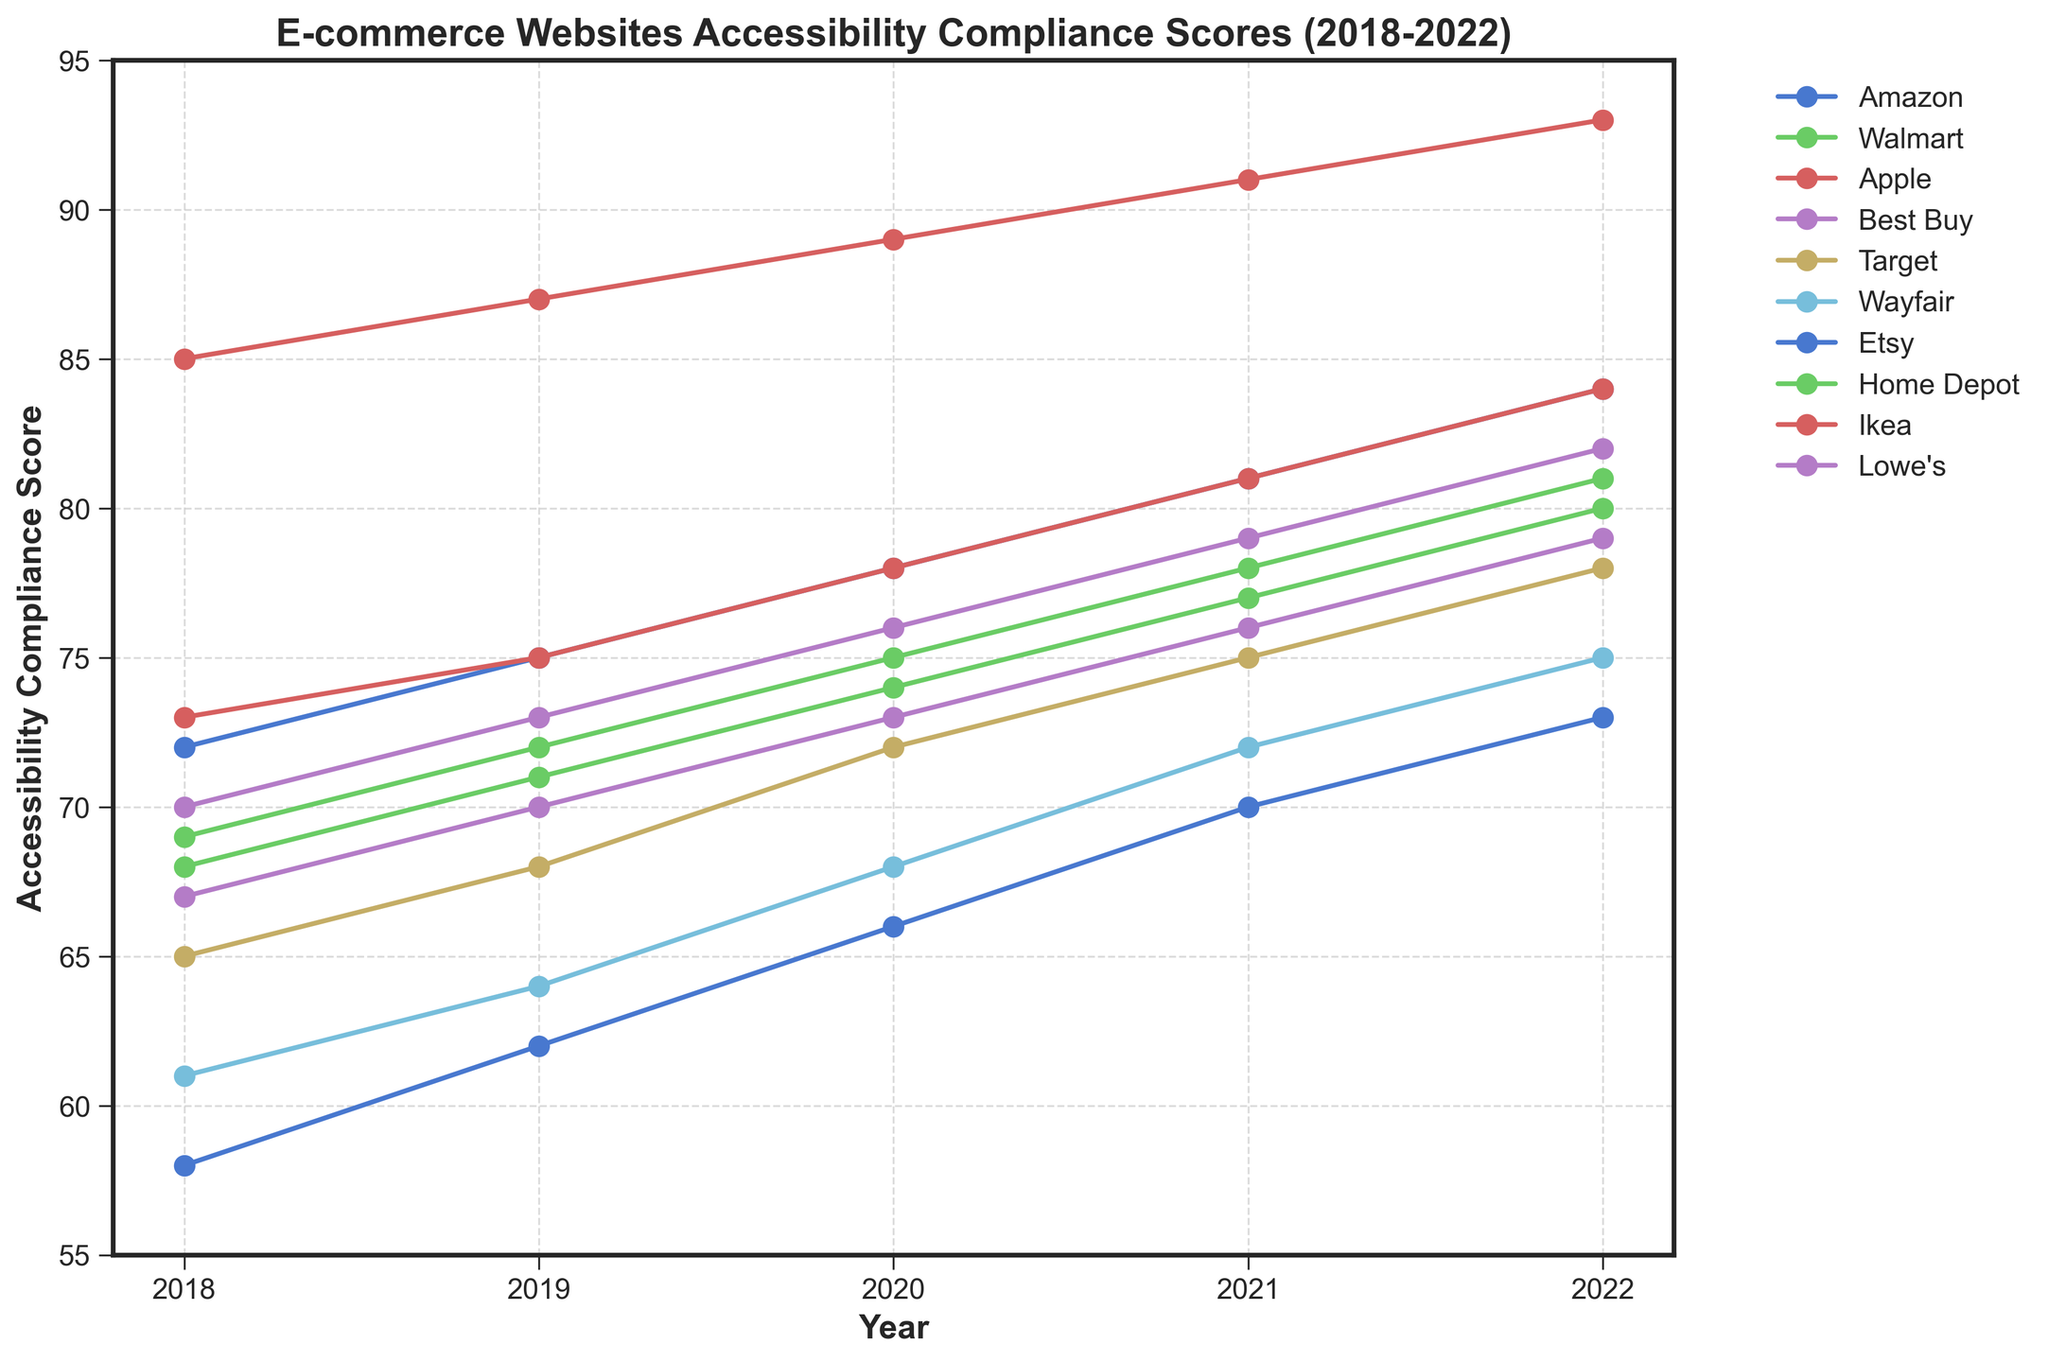Which company had the highest accessibility compliance score in 2022? To find the company's accessibility compliance score in 2022, look for the highest data point on the y-axis corresponding to the year 2022.
Answer: Apple Which company showed the most consistent improvement in their accessibility compliance scores over the 5 years? Analyze the lines to see which one has the smoothest upward trend without any dips or sudden jumps. Compare lines for consistency.
Answer: Apple What's the total increase in accessibility compliance scores for Walmart from 2018 to 2022? Calculate the difference between the 2022 score and the 2018 score for Walmart. The total increase is 80 - 68 = 12.
Answer: 12 Which companies had a score lower than 70 in 2019? Check the data points for all companies in the year 2019 and identify those below the 70-mark on the y-axis.
Answer: Target, Wayfair, Etsy, Lowe's What is the average accessibility compliance score of Amazon and Best Buy in 2020? Add Amazon's and Best Buy's scores for 2020 and then divide by 2. (78 + 76) / 2 = 77
Answer: 77 Which company had the steepest increase in score between any two consecutive years, and what was the increase? Look at the slopes of the lines between consecutive years for the steepest slope; calculate the difference between the years. Apple's steepest increase is between 2021 and 2022, where the score increased from 91 to 93, which is 93 - 91 = 2.
Answer: Apple, 2 How did Etsy’s score in 2022 compare to its score in 2018? Locate Etsy's scores for the years 2018 and 2022 and find the difference. The score increased from 58 to 73.
Answer: It increased by 15 points By how much did Target's accessibility compliance score change from 2019 to 2020? Subtract Target’s 2019 score from its 2020 score to find the change. 72 - 68 = 4.
Answer: 4 Which company had the lowest accessibility compliance score in 2018 and what was it? Look for the lowest data point in the year 2018 and note the corresponding company.
Answer: Etsy, 58 Are there any companies whose accessibility compliance scores stayed the same between any two consecutive years? Check the lines for any company whose points for two consecutive years are at the same level.
Answer: None 